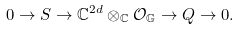<formula> <loc_0><loc_0><loc_500><loc_500>0 \rightarrow S \rightarrow \mathbb { C } ^ { 2 d } \otimes _ { \mathbb { C } } \mathcal { O } _ { \mathbb { G } } \rightarrow Q \rightarrow 0 .</formula> 